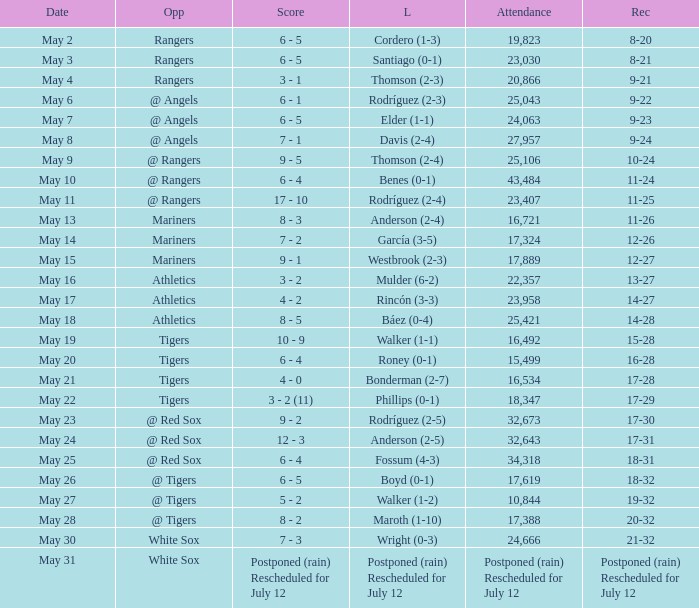What was the Indians record during the game that had 19,823 fans attending? 8-20. 